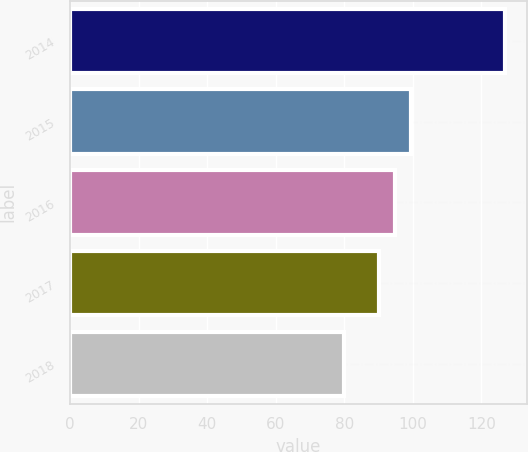<chart> <loc_0><loc_0><loc_500><loc_500><bar_chart><fcel>2014<fcel>2015<fcel>2016<fcel>2017<fcel>2018<nl><fcel>127<fcel>99.4<fcel>94.7<fcel>90<fcel>80<nl></chart> 